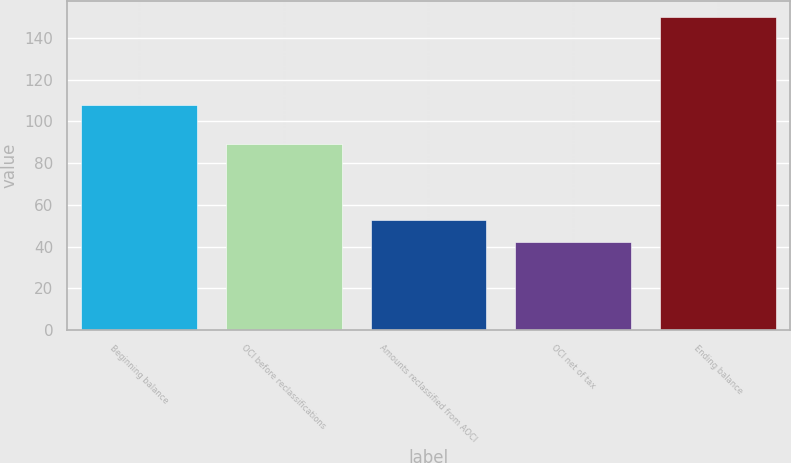Convert chart. <chart><loc_0><loc_0><loc_500><loc_500><bar_chart><fcel>Beginning balance<fcel>OCI before reclassifications<fcel>Amounts reclassified from AOCI<fcel>OCI net of tax<fcel>Ending balance<nl><fcel>108<fcel>89<fcel>52.8<fcel>42<fcel>150<nl></chart> 